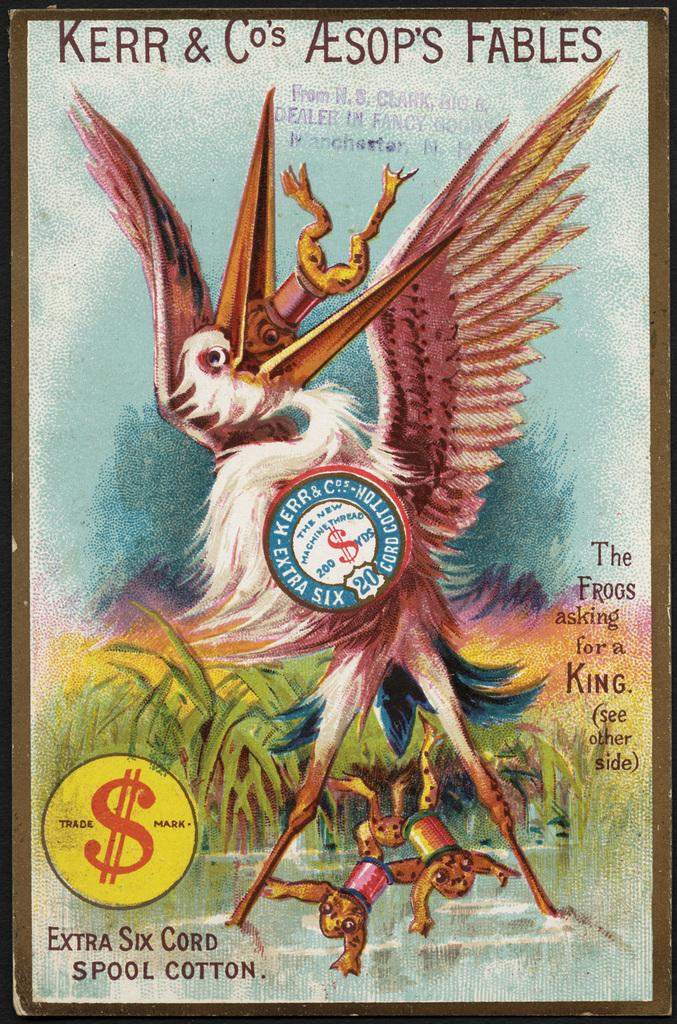Provide a one-sentence caption for the provided image. A copy of Kerr & Co's Aesop's Fables from Manchester NH. 